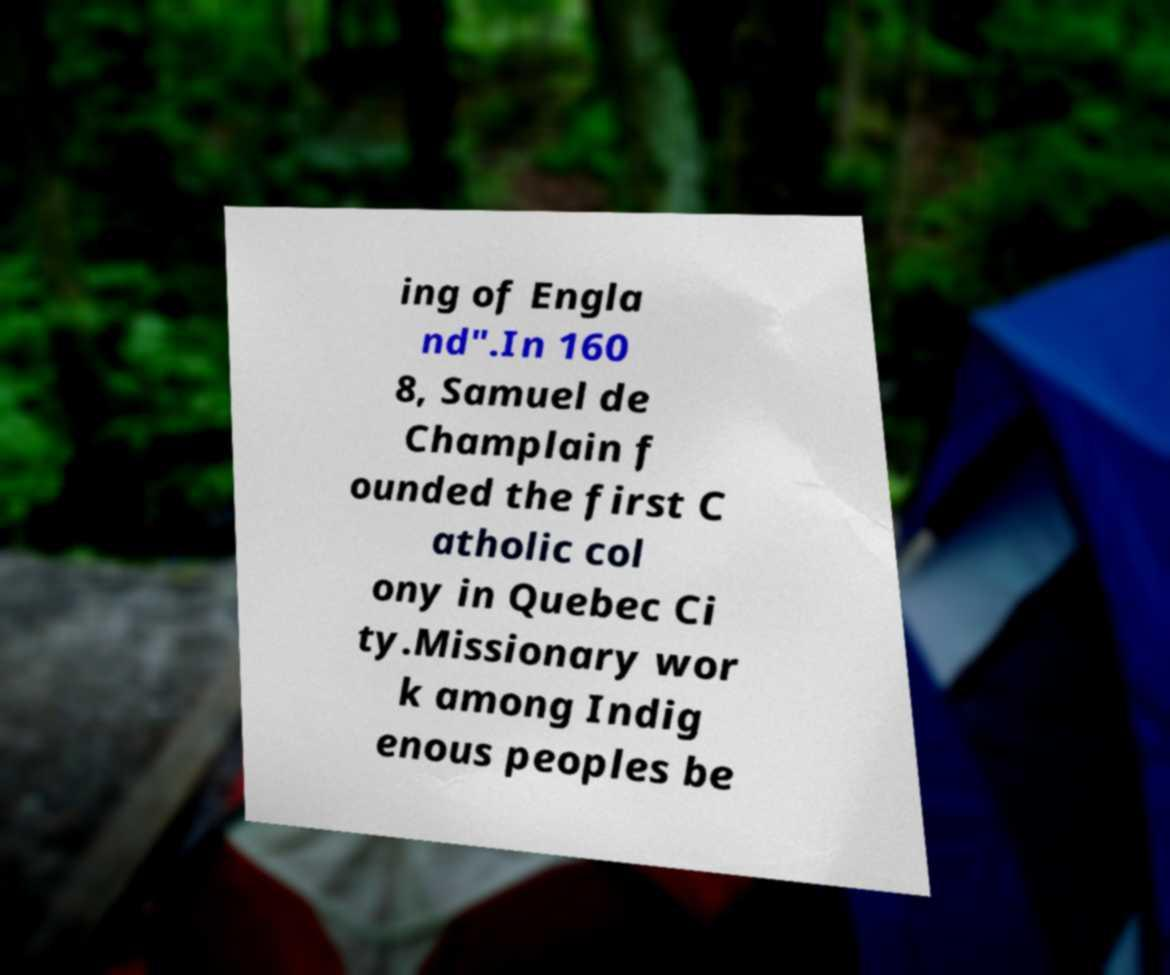Can you read and provide the text displayed in the image?This photo seems to have some interesting text. Can you extract and type it out for me? ing of Engla nd".In 160 8, Samuel de Champlain f ounded the first C atholic col ony in Quebec Ci ty.Missionary wor k among Indig enous peoples be 